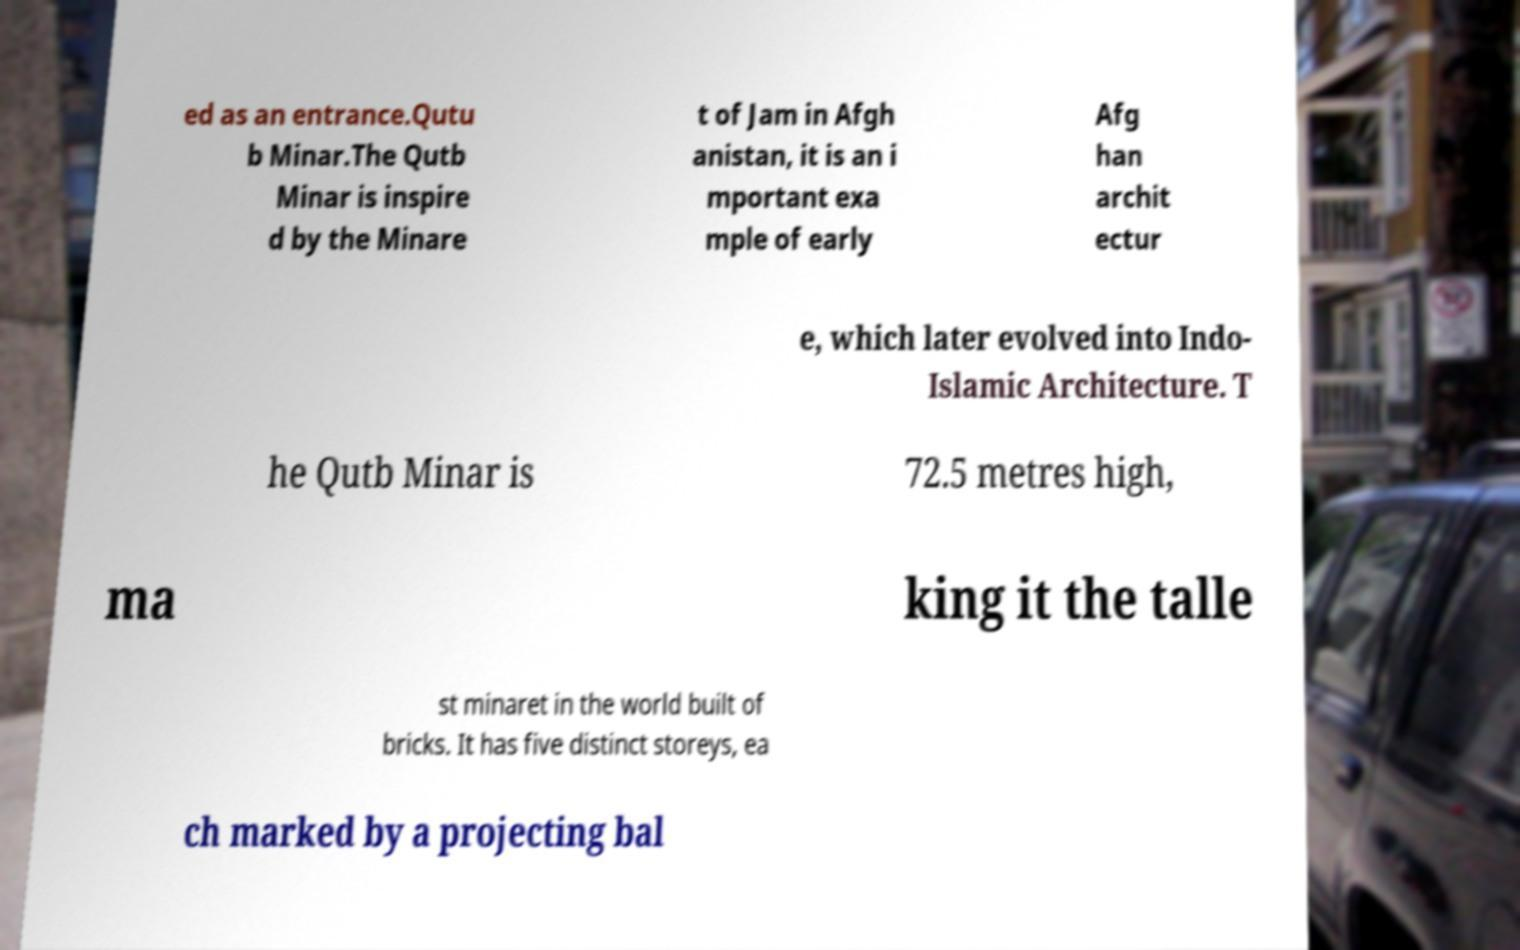There's text embedded in this image that I need extracted. Can you transcribe it verbatim? ed as an entrance.Qutu b Minar.The Qutb Minar is inspire d by the Minare t of Jam in Afgh anistan, it is an i mportant exa mple of early Afg han archit ectur e, which later evolved into Indo- Islamic Architecture. T he Qutb Minar is 72.5 metres high, ma king it the talle st minaret in the world built of bricks. It has five distinct storeys, ea ch marked by a projecting bal 